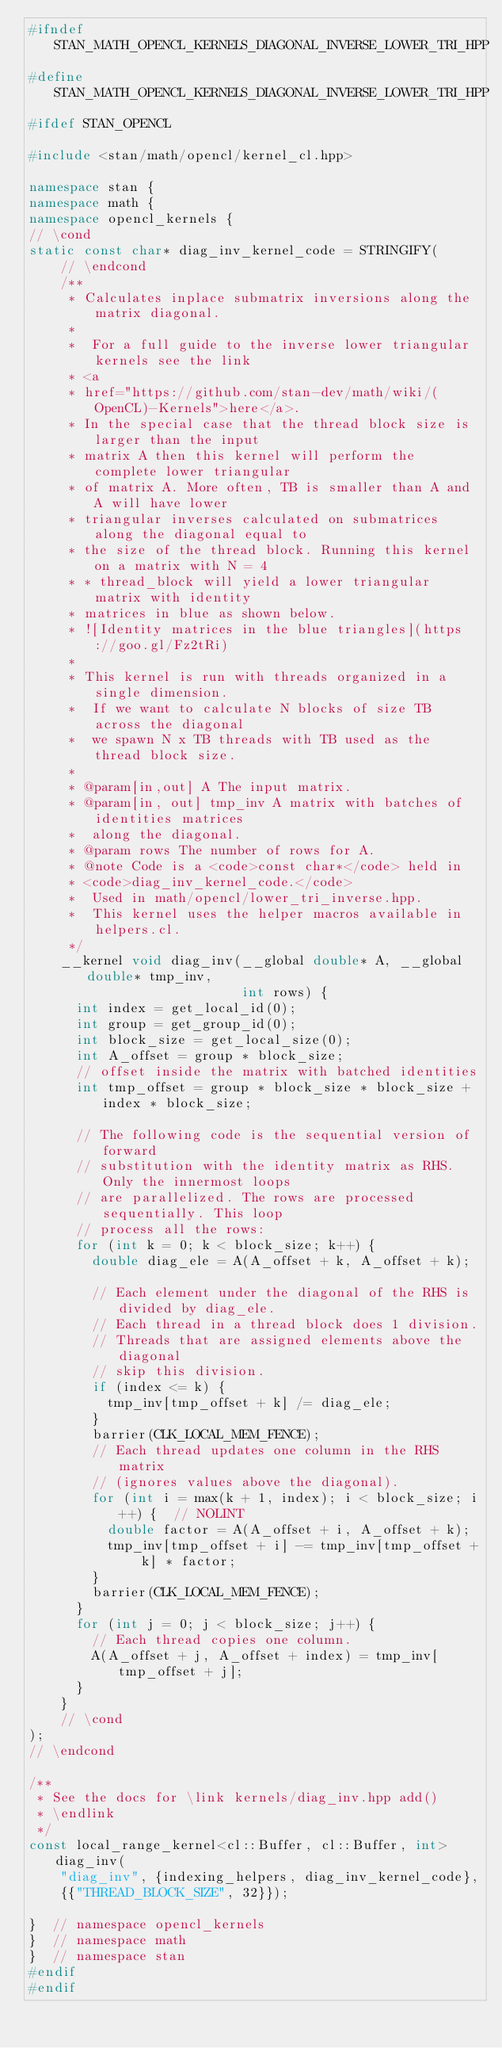<code> <loc_0><loc_0><loc_500><loc_500><_C++_>#ifndef STAN_MATH_OPENCL_KERNELS_DIAGONAL_INVERSE_LOWER_TRI_HPP
#define STAN_MATH_OPENCL_KERNELS_DIAGONAL_INVERSE_LOWER_TRI_HPP
#ifdef STAN_OPENCL

#include <stan/math/opencl/kernel_cl.hpp>

namespace stan {
namespace math {
namespace opencl_kernels {
// \cond
static const char* diag_inv_kernel_code = STRINGIFY(
    // \endcond
    /**
     * Calculates inplace submatrix inversions along the matrix diagonal.
     *
     *  For a full guide to the inverse lower triangular kernels see the link
     * <a
     * href="https://github.com/stan-dev/math/wiki/(OpenCL)-Kernels">here</a>.
     * In the special case that the thread block size is larger than the input
     * matrix A then this kernel will perform the complete lower triangular
     * of matrix A. More often, TB is smaller than A and A will have lower
     * triangular inverses calculated on submatrices along the diagonal equal to
     * the size of the thread block. Running this kernel on a matrix with N = 4
     * * thread_block will yield a lower triangular matrix with identity
     * matrices in blue as shown below.
     * ![Identity matrices in the blue triangles](https://goo.gl/Fz2tRi)
     *
     * This kernel is run with threads organized in a single dimension.
     *  If we want to calculate N blocks of size TB across the diagonal
     *  we spawn N x TB threads with TB used as the thread block size.
     *
     * @param[in,out] A The input matrix.
     * @param[in, out] tmp_inv A matrix with batches of identities matrices
     *  along the diagonal.
     * @param rows The number of rows for A.
     * @note Code is a <code>const char*</code> held in
     * <code>diag_inv_kernel_code.</code>
     *  Used in math/opencl/lower_tri_inverse.hpp.
     *  This kernel uses the helper macros available in helpers.cl.
     */
    __kernel void diag_inv(__global double* A, __global double* tmp_inv,
                           int rows) {
      int index = get_local_id(0);
      int group = get_group_id(0);
      int block_size = get_local_size(0);
      int A_offset = group * block_size;
      // offset inside the matrix with batched identities
      int tmp_offset = group * block_size * block_size + index * block_size;

      // The following code is the sequential version of forward
      // substitution with the identity matrix as RHS. Only the innermost loops
      // are parallelized. The rows are processed sequentially. This loop
      // process all the rows:
      for (int k = 0; k < block_size; k++) {
        double diag_ele = A(A_offset + k, A_offset + k);

        // Each element under the diagonal of the RHS is divided by diag_ele.
        // Each thread in a thread block does 1 division.
        // Threads that are assigned elements above the diagonal
        // skip this division.
        if (index <= k) {
          tmp_inv[tmp_offset + k] /= diag_ele;
        }
        barrier(CLK_LOCAL_MEM_FENCE);
        // Each thread updates one column in the RHS matrix
        // (ignores values above the diagonal).
        for (int i = max(k + 1, index); i < block_size; i++) {  // NOLINT
          double factor = A(A_offset + i, A_offset + k);
          tmp_inv[tmp_offset + i] -= tmp_inv[tmp_offset + k] * factor;
        }
        barrier(CLK_LOCAL_MEM_FENCE);
      }
      for (int j = 0; j < block_size; j++) {
        // Each thread copies one column.
        A(A_offset + j, A_offset + index) = tmp_inv[tmp_offset + j];
      }
    }
    // \cond
);
// \endcond

/**
 * See the docs for \link kernels/diag_inv.hpp add()
 * \endlink
 */
const local_range_kernel<cl::Buffer, cl::Buffer, int> diag_inv(
    "diag_inv", {indexing_helpers, diag_inv_kernel_code},
    {{"THREAD_BLOCK_SIZE", 32}});

}  // namespace opencl_kernels
}  // namespace math
}  // namespace stan
#endif
#endif
</code> 